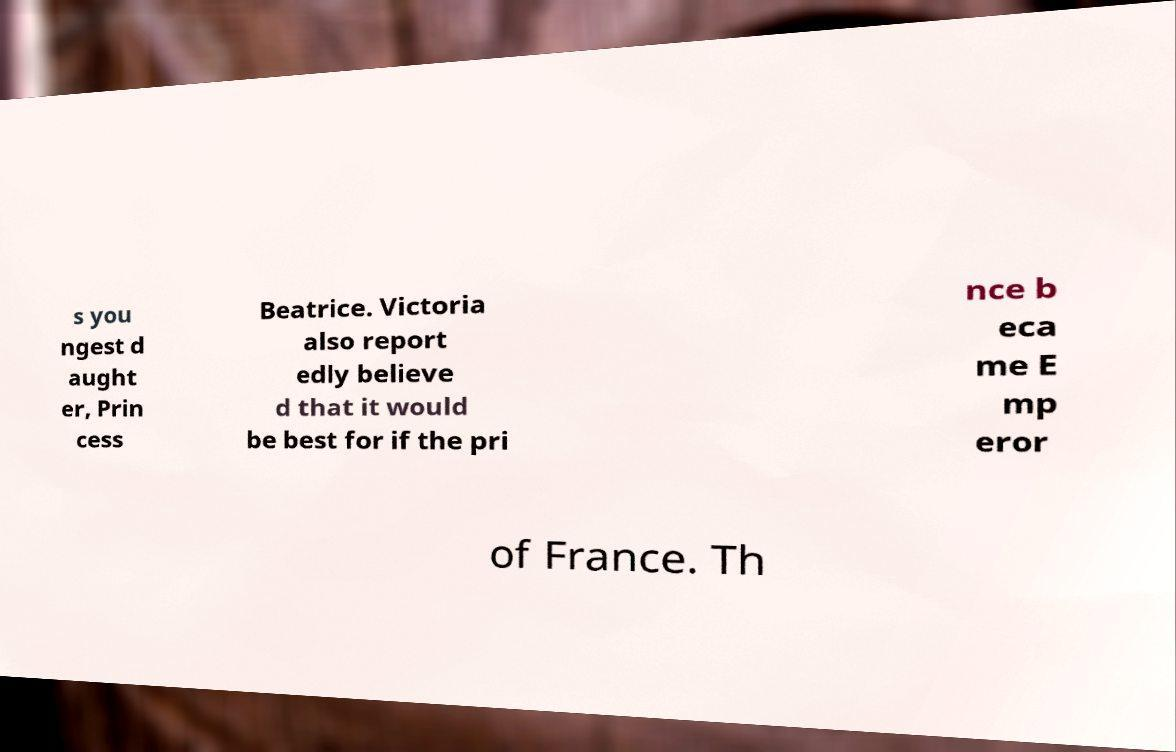Could you assist in decoding the text presented in this image and type it out clearly? s you ngest d aught er, Prin cess Beatrice. Victoria also report edly believe d that it would be best for if the pri nce b eca me E mp eror of France. Th 